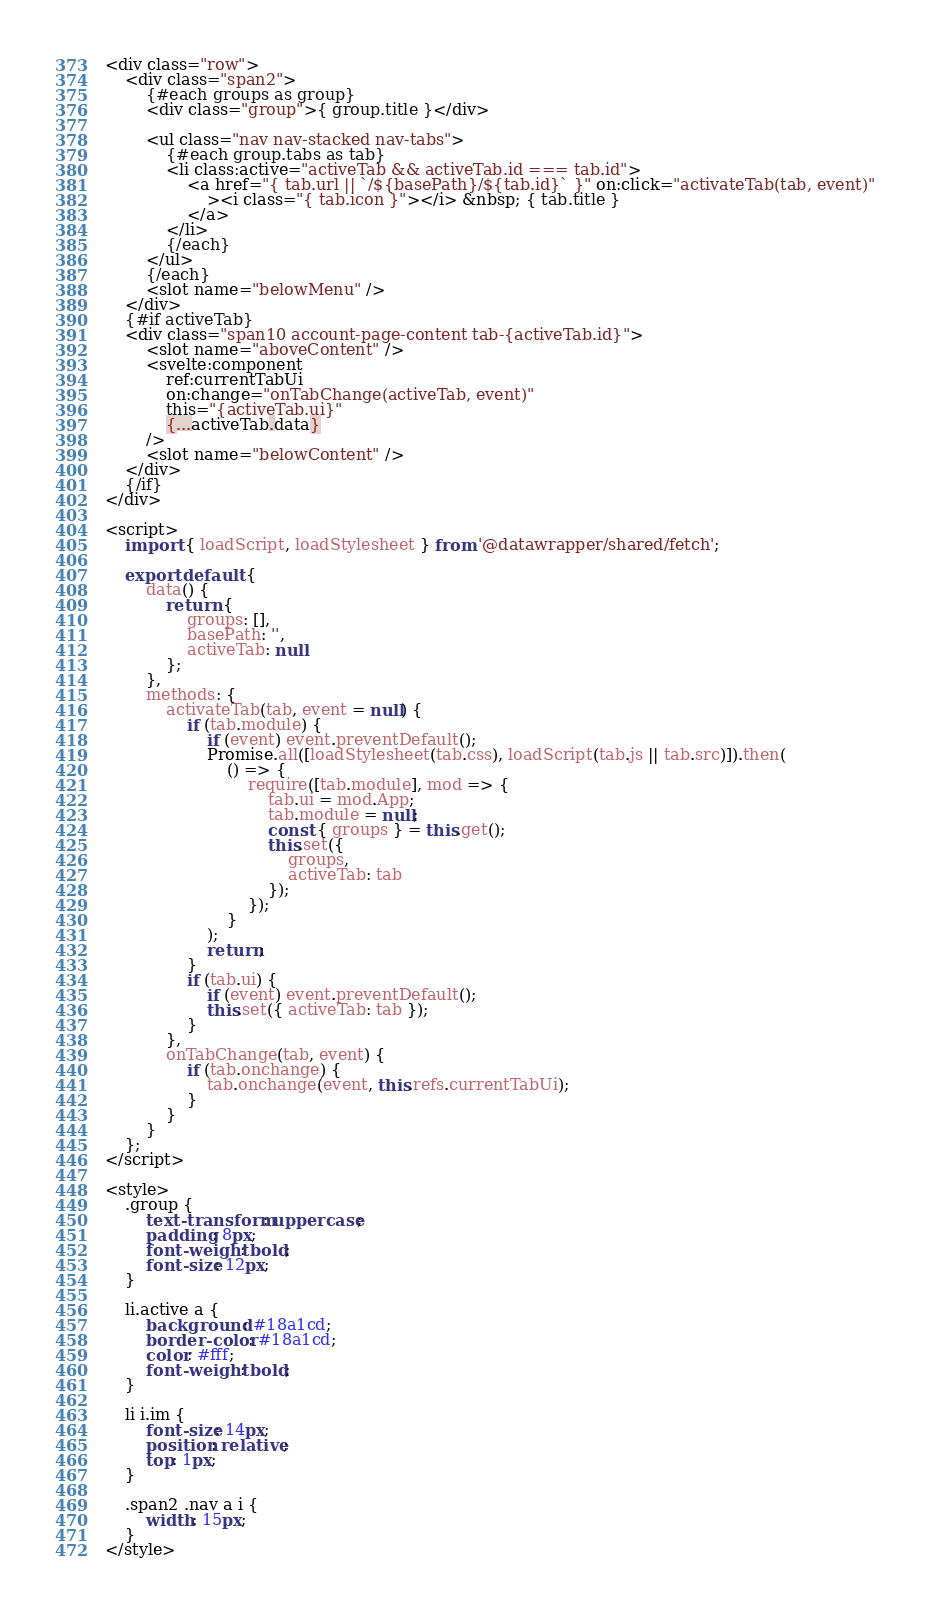Convert code to text. <code><loc_0><loc_0><loc_500><loc_500><_HTML_><div class="row">
    <div class="span2">
        {#each groups as group}
        <div class="group">{ group.title }</div>

        <ul class="nav nav-stacked nav-tabs">
            {#each group.tabs as tab}
            <li class:active="activeTab && activeTab.id === tab.id">
                <a href="{ tab.url || `/${basePath}/${tab.id}` }" on:click="activateTab(tab, event)"
                    ><i class="{ tab.icon }"></i> &nbsp; { tab.title }
                </a>
            </li>
            {/each}
        </ul>
        {/each}
        <slot name="belowMenu" />
    </div>
    {#if activeTab}
    <div class="span10 account-page-content tab-{activeTab.id}">
        <slot name="aboveContent" />
        <svelte:component
            ref:currentTabUi
            on:change="onTabChange(activeTab, event)"
            this="{activeTab.ui}"
            {...activeTab.data}
        />
        <slot name="belowContent" />
    </div>
    {/if}
</div>

<script>
    import { loadScript, loadStylesheet } from '@datawrapper/shared/fetch';

    export default {
        data() {
            return {
                groups: [],
                basePath: '',
                activeTab: null
            };
        },
        methods: {
            activateTab(tab, event = null) {
                if (tab.module) {
                    if (event) event.preventDefault();
                    Promise.all([loadStylesheet(tab.css), loadScript(tab.js || tab.src)]).then(
                        () => {
                            require([tab.module], mod => {
                                tab.ui = mod.App;
                                tab.module = null;
                                const { groups } = this.get();
                                this.set({
                                    groups,
                                    activeTab: tab
                                });
                            });
                        }
                    );
                    return;
                }
                if (tab.ui) {
                    if (event) event.preventDefault();
                    this.set({ activeTab: tab });
                }
            },
            onTabChange(tab, event) {
                if (tab.onchange) {
                    tab.onchange(event, this.refs.currentTabUi);
                }
            }
        }
    };
</script>

<style>
    .group {
        text-transform: uppercase;
        padding: 8px;
        font-weight: bold;
        font-size: 12px;
    }

    li.active a {
        background: #18a1cd;
        border-color: #18a1cd;
        color: #fff;
        font-weight: bold;
    }

    li i.im {
        font-size: 14px;
        position: relative;
        top: 1px;
    }

    .span2 .nav a i {
        width: 15px;
    }
</style>
</code> 